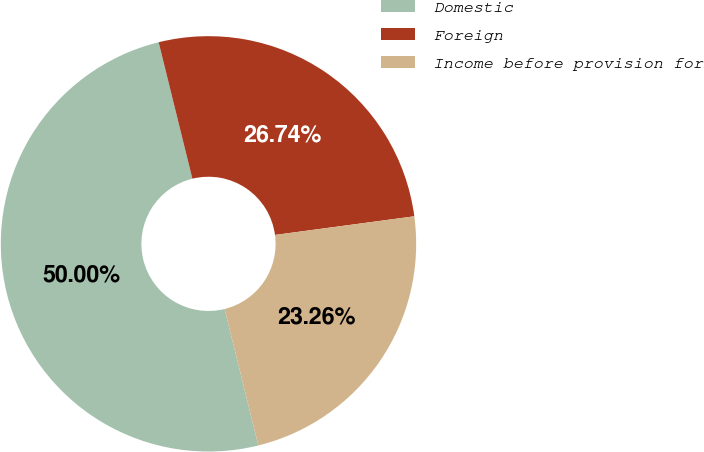Convert chart to OTSL. <chart><loc_0><loc_0><loc_500><loc_500><pie_chart><fcel>Domestic<fcel>Foreign<fcel>Income before provision for<nl><fcel>50.0%<fcel>26.74%<fcel>23.26%<nl></chart> 